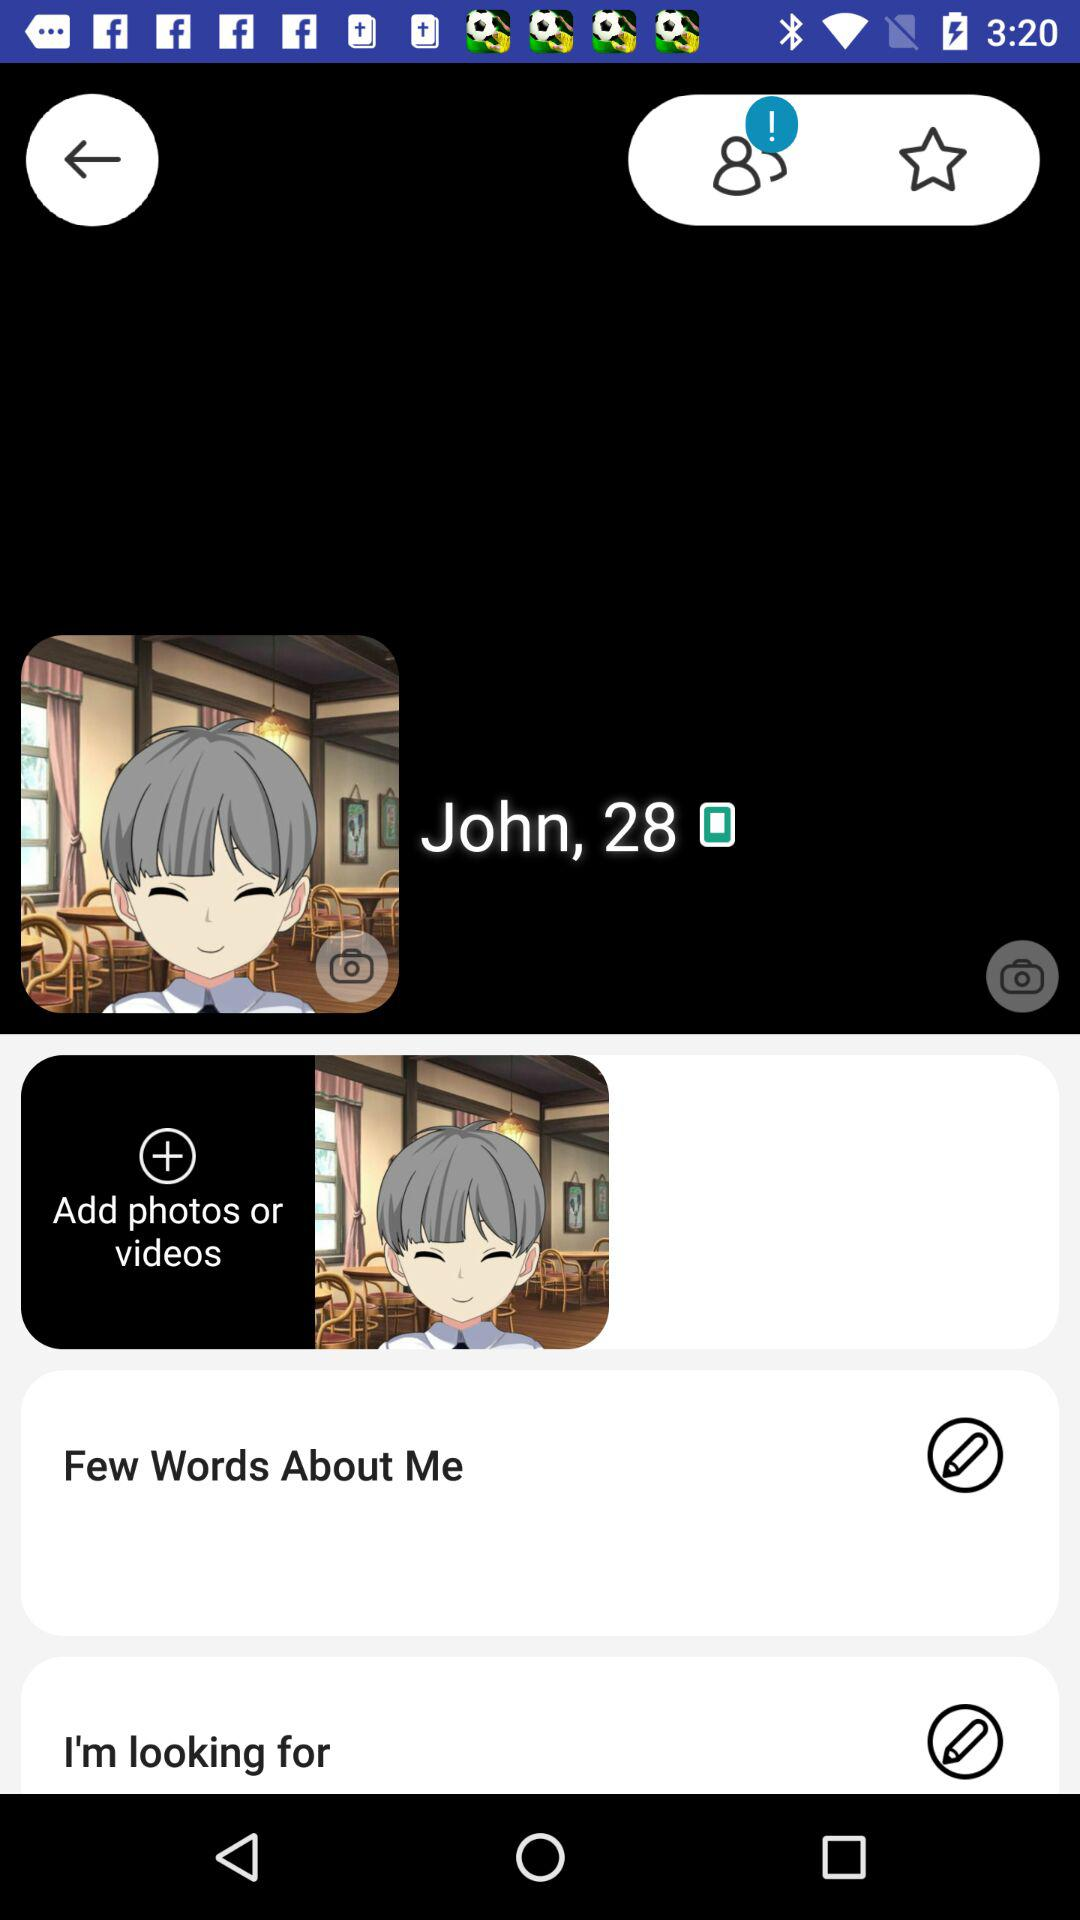What is the mentioned age? The mentioned age is 28. 